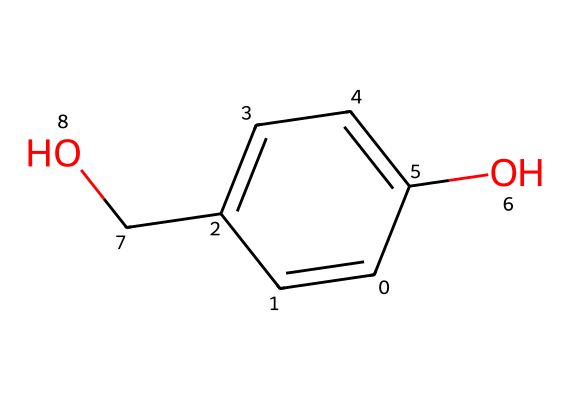What is the primary functional group in this chemical? The chemical structure contains a hydroxyl group (-OH) directly attached to a carbon atom, which classifies it as an alcohol, specifically phenol.
Answer: hydroxyl group How many carbon atoms are present in the molecule? By analyzing the SMILES representation, we can identify a total of five carbon atoms within the structure. Each 'C' counts as one carbon atom contributing to the overall count.
Answer: five What type of isomerism is this chemical capable of exhibiting? Given the presence of a hydroxyl group and potentially varying arrangements of the remaining atoms, the molecule can exhibit positional isomerism where the location of substituents can change.
Answer: positional isomerism What is the molecular formula derived from the SMILES structure? By counting all the atoms represented, there are six carbon atoms, six hydrogen atoms, and two oxygen atoms, leading to the molecular formula C6H6O2.
Answer: C6H6O2 Does this chemical structure indicate the presence of any aromatic rings? Observing the double bonds in the carbon chain, it’s clear that the structure includes an aromatic ring, characterized by alternating double bonds (indicating resonance stability).
Answer: yes What is the oxidation state of carbon in the hydroxyl group? In the hydroxyl group (-OH), the carbon is attached to an oxygen with a single bond, which indicates it is in the -OH functional form; generally, carbon in this functional group shows an oxidation state of -1 when considering its bonding nature.
Answer: -1 How does the presence of hydroxyl and additional functional groups affect the solubility of this chemical? The presence of a hydroxyl group enhances hydrogen bonding with water, increasing the solubility of the chemical in aqueous solutions, which is a characteristic of phenolic compounds.
Answer: increases solubility 